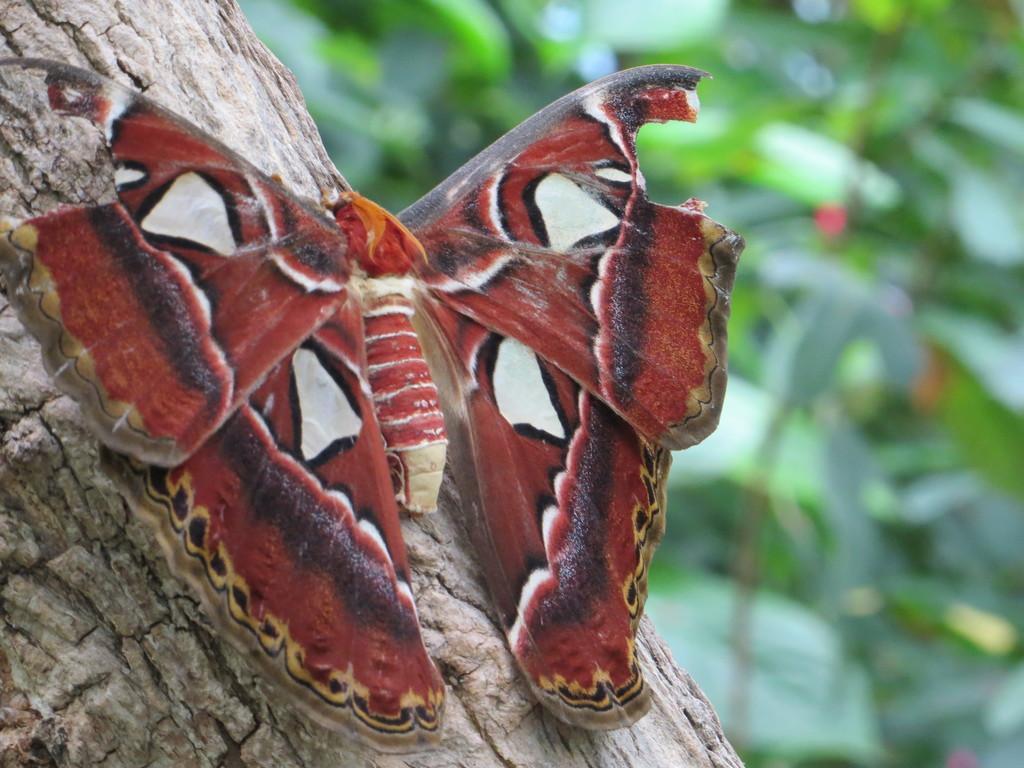Describe this image in one or two sentences. On the left side of the image we can see a butterfly on a tree. There is a blur background with greenery. 